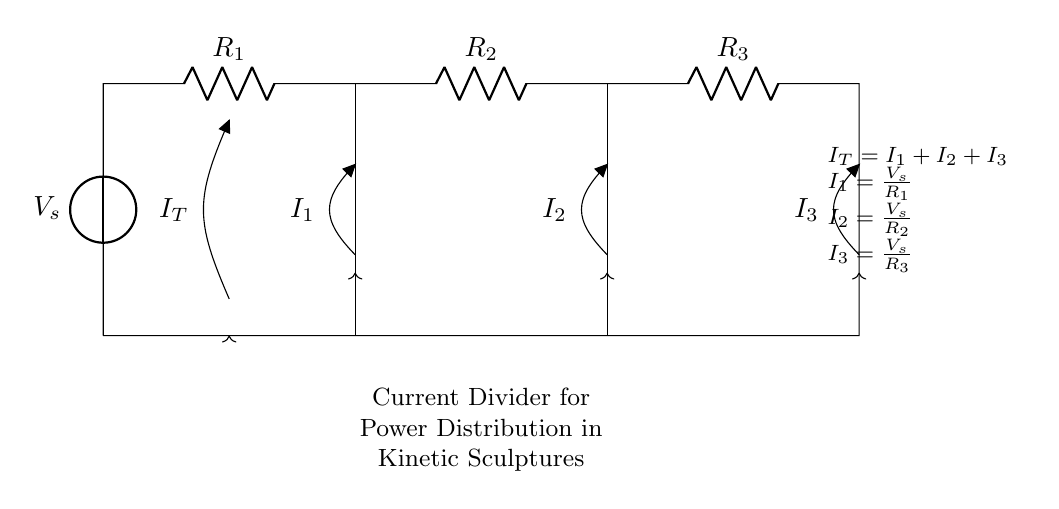What does V_s represent in the circuit? V_s represents the source voltage in the circuit. It provides the electrical potential difference needed for current to flow through the resistors connected in parallel.
Answer: source voltage How many resistors are present in the circuit? There are three resistors (R_1, R_2, and R_3) shown in the circuit diagram, each connected in parallel. This allows for current division among them.
Answer: three What is the relationship between I_T and I_1, I_2, I_3? I_T is the total current flowing from the source and equals the sum of the individual currents I_1, I_2, and I_3 flowing through the resistors. This is a fundamental principle of parallel circuits.
Answer: I_T = I_1 + I_2 + I_3 If R_1 is 2 ohms, what is the value of I_1 if V_s is 10 volts? To find I_1, use Ohm's Law: I_1 = V_s / R_1. Substituting the values gives I_1 = 10V / 2Ω = 5A. This shows how current through each resistor can be calculated independently in a current divider circuit.
Answer: 5A Can any of the resistors have a higher current than I_T? No, in a parallel circuit, the individual currents through each resistor can’t exceed the total current I_T supplied by the source. Each resistor will share the total current according to its resistance value.
Answer: No What happens to the total current if one resistor is removed? If one resistor is removed, the total current I_T will increase as there are fewer pathways for the current to divide. The remaining resistors will carry more current since they will still be connected to the same voltage source.
Answer: increases 